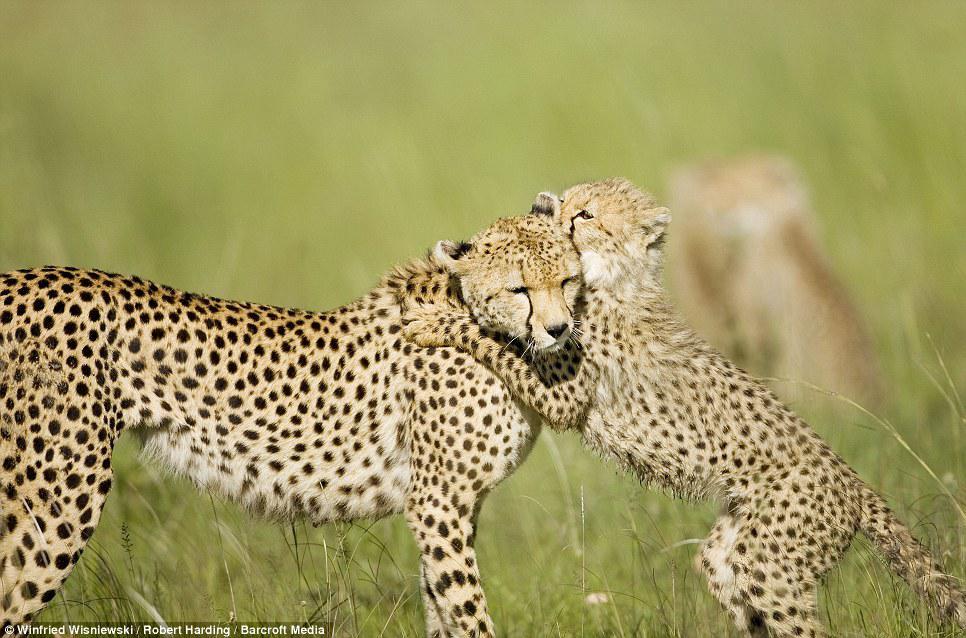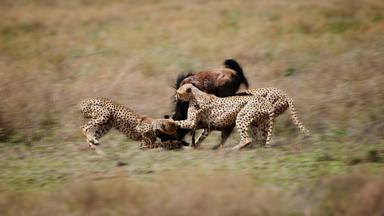The first image is the image on the left, the second image is the image on the right. For the images shown, is this caption "There are no more than four cheetahs." true? Answer yes or no. No. The first image is the image on the left, the second image is the image on the right. Evaluate the accuracy of this statement regarding the images: "Left image shows spotted wild cats attacking an upright hooved animal.". Is it true? Answer yes or no. No. 